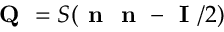Convert formula to latex. <formula><loc_0><loc_0><loc_500><loc_500>Q = S ( n n - I / 2 )</formula> 